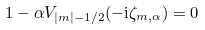<formula> <loc_0><loc_0><loc_500><loc_500>1 - \alpha V _ { | m | - 1 / 2 } ( - \mathrm i \zeta _ { m , \alpha } ) = 0</formula> 